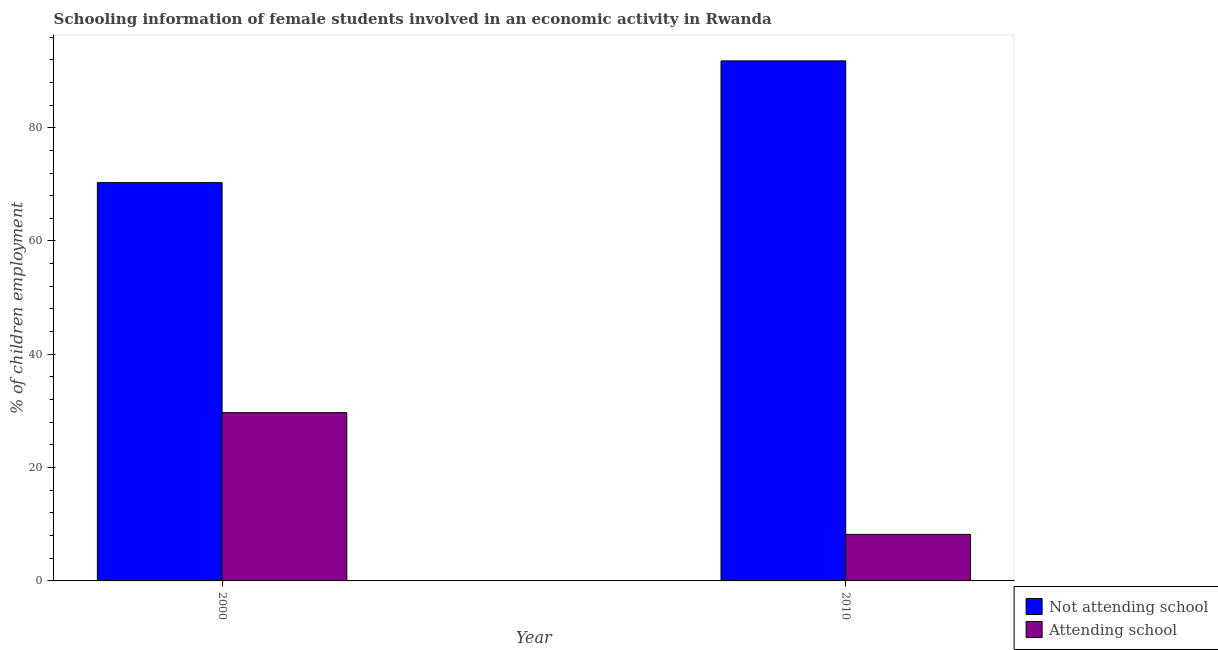How many groups of bars are there?
Ensure brevity in your answer.  2. Are the number of bars per tick equal to the number of legend labels?
Your answer should be very brief. Yes. How many bars are there on the 1st tick from the left?
Offer a very short reply. 2. In how many cases, is the number of bars for a given year not equal to the number of legend labels?
Provide a succinct answer. 0. What is the percentage of employed females who are not attending school in 2010?
Your answer should be very brief. 91.79. Across all years, what is the maximum percentage of employed females who are not attending school?
Make the answer very short. 91.79. Across all years, what is the minimum percentage of employed females who are attending school?
Offer a terse response. 8.21. What is the total percentage of employed females who are not attending school in the graph?
Your answer should be very brief. 162.09. What is the difference between the percentage of employed females who are not attending school in 2000 and that in 2010?
Your answer should be compact. -21.49. What is the difference between the percentage of employed females who are not attending school in 2010 and the percentage of employed females who are attending school in 2000?
Offer a very short reply. 21.49. What is the average percentage of employed females who are attending school per year?
Offer a very short reply. 18.96. In the year 2000, what is the difference between the percentage of employed females who are not attending school and percentage of employed females who are attending school?
Your answer should be very brief. 0. In how many years, is the percentage of employed females who are not attending school greater than 4 %?
Your answer should be compact. 2. What is the ratio of the percentage of employed females who are not attending school in 2000 to that in 2010?
Provide a short and direct response. 0.77. What does the 2nd bar from the left in 2010 represents?
Give a very brief answer. Attending school. What does the 2nd bar from the right in 2010 represents?
Provide a succinct answer. Not attending school. How many bars are there?
Your answer should be compact. 4. Are all the bars in the graph horizontal?
Ensure brevity in your answer.  No. Are the values on the major ticks of Y-axis written in scientific E-notation?
Offer a terse response. No. Does the graph contain any zero values?
Ensure brevity in your answer.  No. Where does the legend appear in the graph?
Make the answer very short. Bottom right. What is the title of the graph?
Keep it short and to the point. Schooling information of female students involved in an economic activity in Rwanda. Does "Enforce a contract" appear as one of the legend labels in the graph?
Your answer should be compact. No. What is the label or title of the X-axis?
Your response must be concise. Year. What is the label or title of the Y-axis?
Your answer should be compact. % of children employment. What is the % of children employment of Not attending school in 2000?
Your answer should be compact. 70.3. What is the % of children employment of Attending school in 2000?
Offer a terse response. 29.7. What is the % of children employment of Not attending school in 2010?
Make the answer very short. 91.79. What is the % of children employment of Attending school in 2010?
Make the answer very short. 8.21. Across all years, what is the maximum % of children employment of Not attending school?
Offer a terse response. 91.79. Across all years, what is the maximum % of children employment in Attending school?
Your response must be concise. 29.7. Across all years, what is the minimum % of children employment in Not attending school?
Ensure brevity in your answer.  70.3. Across all years, what is the minimum % of children employment of Attending school?
Your answer should be very brief. 8.21. What is the total % of children employment of Not attending school in the graph?
Provide a succinct answer. 162.09. What is the total % of children employment of Attending school in the graph?
Ensure brevity in your answer.  37.91. What is the difference between the % of children employment in Not attending school in 2000 and that in 2010?
Give a very brief answer. -21.49. What is the difference between the % of children employment of Attending school in 2000 and that in 2010?
Provide a succinct answer. 21.49. What is the difference between the % of children employment of Not attending school in 2000 and the % of children employment of Attending school in 2010?
Your response must be concise. 62.09. What is the average % of children employment in Not attending school per year?
Provide a short and direct response. 81.04. What is the average % of children employment in Attending school per year?
Your response must be concise. 18.96. In the year 2000, what is the difference between the % of children employment in Not attending school and % of children employment in Attending school?
Your response must be concise. 40.59. In the year 2010, what is the difference between the % of children employment in Not attending school and % of children employment in Attending school?
Make the answer very short. 83.58. What is the ratio of the % of children employment of Not attending school in 2000 to that in 2010?
Your response must be concise. 0.77. What is the ratio of the % of children employment of Attending school in 2000 to that in 2010?
Your response must be concise. 3.62. What is the difference between the highest and the second highest % of children employment in Not attending school?
Your response must be concise. 21.49. What is the difference between the highest and the second highest % of children employment of Attending school?
Your answer should be very brief. 21.49. What is the difference between the highest and the lowest % of children employment in Not attending school?
Offer a very short reply. 21.49. What is the difference between the highest and the lowest % of children employment of Attending school?
Your answer should be very brief. 21.49. 